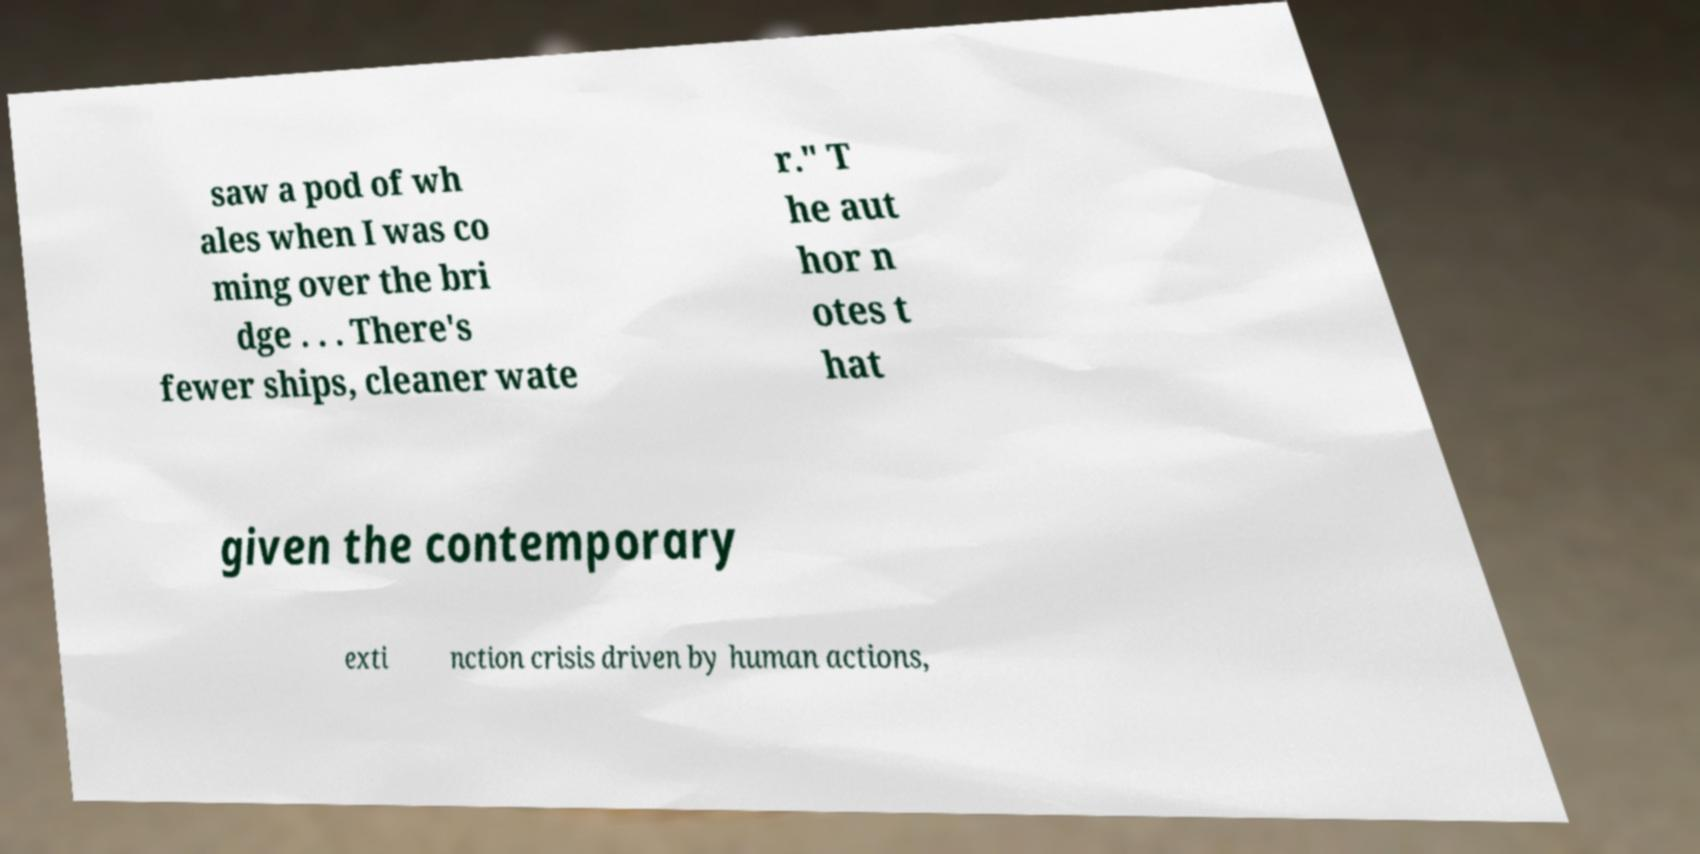I need the written content from this picture converted into text. Can you do that? saw a pod of wh ales when I was co ming over the bri dge . . . There's fewer ships, cleaner wate r." T he aut hor n otes t hat given the contemporary exti nction crisis driven by human actions, 